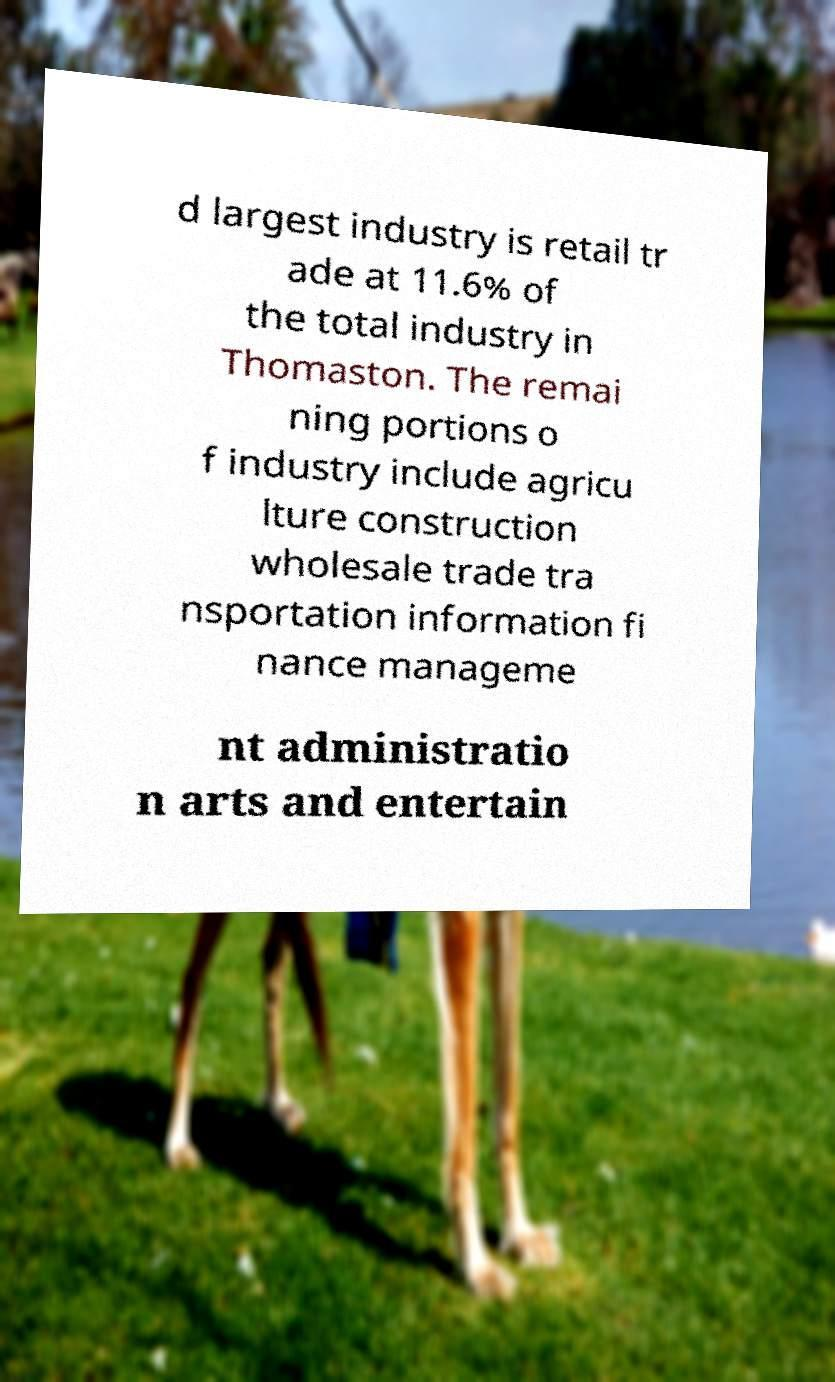Can you read and provide the text displayed in the image?This photo seems to have some interesting text. Can you extract and type it out for me? d largest industry is retail tr ade at 11.6% of the total industry in Thomaston. The remai ning portions o f industry include agricu lture construction wholesale trade tra nsportation information fi nance manageme nt administratio n arts and entertain 